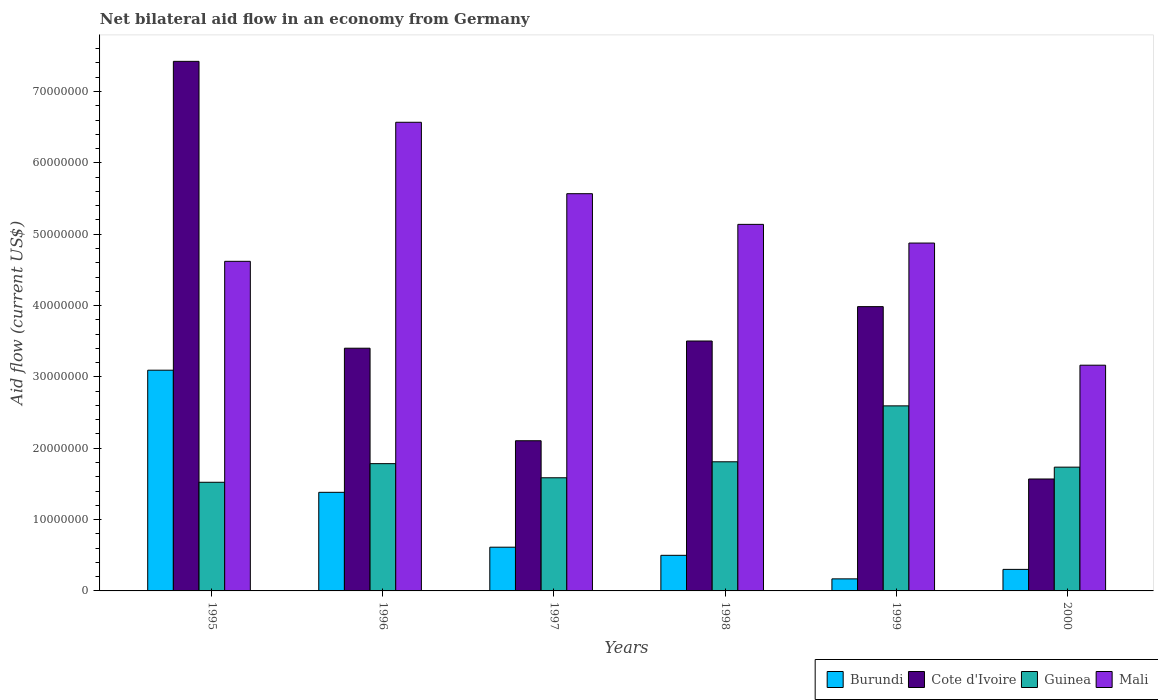Are the number of bars on each tick of the X-axis equal?
Your answer should be compact. Yes. How many bars are there on the 6th tick from the left?
Your response must be concise. 4. What is the label of the 1st group of bars from the left?
Provide a short and direct response. 1995. In how many cases, is the number of bars for a given year not equal to the number of legend labels?
Provide a succinct answer. 0. What is the net bilateral aid flow in Guinea in 1997?
Keep it short and to the point. 1.59e+07. Across all years, what is the maximum net bilateral aid flow in Mali?
Your answer should be very brief. 6.57e+07. Across all years, what is the minimum net bilateral aid flow in Cote d'Ivoire?
Offer a terse response. 1.57e+07. In which year was the net bilateral aid flow in Burundi minimum?
Your response must be concise. 1999. What is the total net bilateral aid flow in Cote d'Ivoire in the graph?
Your answer should be very brief. 2.20e+08. What is the difference between the net bilateral aid flow in Burundi in 1997 and that in 1999?
Give a very brief answer. 4.44e+06. What is the difference between the net bilateral aid flow in Burundi in 1998 and the net bilateral aid flow in Cote d'Ivoire in 1996?
Keep it short and to the point. -2.90e+07. What is the average net bilateral aid flow in Burundi per year?
Keep it short and to the point. 1.01e+07. In the year 1997, what is the difference between the net bilateral aid flow in Burundi and net bilateral aid flow in Cote d'Ivoire?
Offer a very short reply. -1.49e+07. In how many years, is the net bilateral aid flow in Mali greater than 74000000 US$?
Ensure brevity in your answer.  0. What is the ratio of the net bilateral aid flow in Guinea in 1997 to that in 2000?
Your answer should be very brief. 0.91. Is the difference between the net bilateral aid flow in Burundi in 1996 and 1998 greater than the difference between the net bilateral aid flow in Cote d'Ivoire in 1996 and 1998?
Provide a succinct answer. Yes. What is the difference between the highest and the second highest net bilateral aid flow in Burundi?
Your answer should be very brief. 1.71e+07. What is the difference between the highest and the lowest net bilateral aid flow in Guinea?
Offer a very short reply. 1.07e+07. In how many years, is the net bilateral aid flow in Guinea greater than the average net bilateral aid flow in Guinea taken over all years?
Ensure brevity in your answer.  1. Is it the case that in every year, the sum of the net bilateral aid flow in Burundi and net bilateral aid flow in Guinea is greater than the sum of net bilateral aid flow in Mali and net bilateral aid flow in Cote d'Ivoire?
Keep it short and to the point. No. What does the 2nd bar from the left in 1997 represents?
Provide a short and direct response. Cote d'Ivoire. What does the 1st bar from the right in 1999 represents?
Your answer should be very brief. Mali. Are the values on the major ticks of Y-axis written in scientific E-notation?
Keep it short and to the point. No. Does the graph contain grids?
Make the answer very short. No. What is the title of the graph?
Your answer should be compact. Net bilateral aid flow in an economy from Germany. What is the label or title of the Y-axis?
Make the answer very short. Aid flow (current US$). What is the Aid flow (current US$) of Burundi in 1995?
Your response must be concise. 3.09e+07. What is the Aid flow (current US$) in Cote d'Ivoire in 1995?
Your answer should be very brief. 7.42e+07. What is the Aid flow (current US$) in Guinea in 1995?
Keep it short and to the point. 1.52e+07. What is the Aid flow (current US$) of Mali in 1995?
Offer a very short reply. 4.62e+07. What is the Aid flow (current US$) in Burundi in 1996?
Provide a succinct answer. 1.38e+07. What is the Aid flow (current US$) of Cote d'Ivoire in 1996?
Offer a terse response. 3.40e+07. What is the Aid flow (current US$) of Guinea in 1996?
Provide a succinct answer. 1.78e+07. What is the Aid flow (current US$) of Mali in 1996?
Your response must be concise. 6.57e+07. What is the Aid flow (current US$) of Burundi in 1997?
Give a very brief answer. 6.13e+06. What is the Aid flow (current US$) of Cote d'Ivoire in 1997?
Ensure brevity in your answer.  2.10e+07. What is the Aid flow (current US$) of Guinea in 1997?
Provide a short and direct response. 1.59e+07. What is the Aid flow (current US$) of Mali in 1997?
Give a very brief answer. 5.57e+07. What is the Aid flow (current US$) of Burundi in 1998?
Keep it short and to the point. 4.99e+06. What is the Aid flow (current US$) in Cote d'Ivoire in 1998?
Provide a succinct answer. 3.50e+07. What is the Aid flow (current US$) in Guinea in 1998?
Give a very brief answer. 1.81e+07. What is the Aid flow (current US$) in Mali in 1998?
Provide a short and direct response. 5.14e+07. What is the Aid flow (current US$) in Burundi in 1999?
Offer a terse response. 1.69e+06. What is the Aid flow (current US$) in Cote d'Ivoire in 1999?
Your answer should be compact. 3.98e+07. What is the Aid flow (current US$) of Guinea in 1999?
Offer a very short reply. 2.59e+07. What is the Aid flow (current US$) of Mali in 1999?
Provide a succinct answer. 4.88e+07. What is the Aid flow (current US$) of Burundi in 2000?
Your answer should be compact. 3.02e+06. What is the Aid flow (current US$) in Cote d'Ivoire in 2000?
Keep it short and to the point. 1.57e+07. What is the Aid flow (current US$) of Guinea in 2000?
Ensure brevity in your answer.  1.74e+07. What is the Aid flow (current US$) of Mali in 2000?
Provide a succinct answer. 3.16e+07. Across all years, what is the maximum Aid flow (current US$) in Burundi?
Make the answer very short. 3.09e+07. Across all years, what is the maximum Aid flow (current US$) in Cote d'Ivoire?
Offer a very short reply. 7.42e+07. Across all years, what is the maximum Aid flow (current US$) of Guinea?
Your response must be concise. 2.59e+07. Across all years, what is the maximum Aid flow (current US$) in Mali?
Provide a succinct answer. 6.57e+07. Across all years, what is the minimum Aid flow (current US$) in Burundi?
Give a very brief answer. 1.69e+06. Across all years, what is the minimum Aid flow (current US$) of Cote d'Ivoire?
Ensure brevity in your answer.  1.57e+07. Across all years, what is the minimum Aid flow (current US$) of Guinea?
Provide a short and direct response. 1.52e+07. Across all years, what is the minimum Aid flow (current US$) of Mali?
Offer a very short reply. 3.16e+07. What is the total Aid flow (current US$) in Burundi in the graph?
Offer a terse response. 6.06e+07. What is the total Aid flow (current US$) in Cote d'Ivoire in the graph?
Offer a very short reply. 2.20e+08. What is the total Aid flow (current US$) of Guinea in the graph?
Keep it short and to the point. 1.10e+08. What is the total Aid flow (current US$) in Mali in the graph?
Offer a terse response. 2.99e+08. What is the difference between the Aid flow (current US$) in Burundi in 1995 and that in 1996?
Offer a very short reply. 1.71e+07. What is the difference between the Aid flow (current US$) in Cote d'Ivoire in 1995 and that in 1996?
Provide a short and direct response. 4.02e+07. What is the difference between the Aid flow (current US$) of Guinea in 1995 and that in 1996?
Give a very brief answer. -2.61e+06. What is the difference between the Aid flow (current US$) of Mali in 1995 and that in 1996?
Your response must be concise. -1.95e+07. What is the difference between the Aid flow (current US$) in Burundi in 1995 and that in 1997?
Offer a very short reply. 2.48e+07. What is the difference between the Aid flow (current US$) of Cote d'Ivoire in 1995 and that in 1997?
Your answer should be very brief. 5.32e+07. What is the difference between the Aid flow (current US$) of Guinea in 1995 and that in 1997?
Ensure brevity in your answer.  -6.30e+05. What is the difference between the Aid flow (current US$) in Mali in 1995 and that in 1997?
Make the answer very short. -9.48e+06. What is the difference between the Aid flow (current US$) in Burundi in 1995 and that in 1998?
Make the answer very short. 2.60e+07. What is the difference between the Aid flow (current US$) of Cote d'Ivoire in 1995 and that in 1998?
Your answer should be compact. 3.92e+07. What is the difference between the Aid flow (current US$) of Guinea in 1995 and that in 1998?
Offer a very short reply. -2.87e+06. What is the difference between the Aid flow (current US$) in Mali in 1995 and that in 1998?
Provide a succinct answer. -5.18e+06. What is the difference between the Aid flow (current US$) of Burundi in 1995 and that in 1999?
Provide a short and direct response. 2.92e+07. What is the difference between the Aid flow (current US$) in Cote d'Ivoire in 1995 and that in 1999?
Give a very brief answer. 3.44e+07. What is the difference between the Aid flow (current US$) in Guinea in 1995 and that in 1999?
Your answer should be compact. -1.07e+07. What is the difference between the Aid flow (current US$) of Mali in 1995 and that in 1999?
Offer a very short reply. -2.56e+06. What is the difference between the Aid flow (current US$) in Burundi in 1995 and that in 2000?
Provide a succinct answer. 2.79e+07. What is the difference between the Aid flow (current US$) in Cote d'Ivoire in 1995 and that in 2000?
Keep it short and to the point. 5.85e+07. What is the difference between the Aid flow (current US$) of Guinea in 1995 and that in 2000?
Provide a short and direct response. -2.12e+06. What is the difference between the Aid flow (current US$) of Mali in 1995 and that in 2000?
Make the answer very short. 1.46e+07. What is the difference between the Aid flow (current US$) in Burundi in 1996 and that in 1997?
Make the answer very short. 7.69e+06. What is the difference between the Aid flow (current US$) of Cote d'Ivoire in 1996 and that in 1997?
Give a very brief answer. 1.30e+07. What is the difference between the Aid flow (current US$) of Guinea in 1996 and that in 1997?
Make the answer very short. 1.98e+06. What is the difference between the Aid flow (current US$) in Mali in 1996 and that in 1997?
Provide a short and direct response. 1.00e+07. What is the difference between the Aid flow (current US$) of Burundi in 1996 and that in 1998?
Your response must be concise. 8.83e+06. What is the difference between the Aid flow (current US$) in Cote d'Ivoire in 1996 and that in 1998?
Make the answer very short. -1.01e+06. What is the difference between the Aid flow (current US$) in Mali in 1996 and that in 1998?
Provide a short and direct response. 1.43e+07. What is the difference between the Aid flow (current US$) in Burundi in 1996 and that in 1999?
Provide a short and direct response. 1.21e+07. What is the difference between the Aid flow (current US$) in Cote d'Ivoire in 1996 and that in 1999?
Keep it short and to the point. -5.83e+06. What is the difference between the Aid flow (current US$) in Guinea in 1996 and that in 1999?
Provide a short and direct response. -8.10e+06. What is the difference between the Aid flow (current US$) in Mali in 1996 and that in 1999?
Give a very brief answer. 1.69e+07. What is the difference between the Aid flow (current US$) of Burundi in 1996 and that in 2000?
Give a very brief answer. 1.08e+07. What is the difference between the Aid flow (current US$) of Cote d'Ivoire in 1996 and that in 2000?
Your answer should be compact. 1.83e+07. What is the difference between the Aid flow (current US$) of Mali in 1996 and that in 2000?
Make the answer very short. 3.40e+07. What is the difference between the Aid flow (current US$) of Burundi in 1997 and that in 1998?
Your answer should be very brief. 1.14e+06. What is the difference between the Aid flow (current US$) of Cote d'Ivoire in 1997 and that in 1998?
Provide a short and direct response. -1.40e+07. What is the difference between the Aid flow (current US$) of Guinea in 1997 and that in 1998?
Offer a terse response. -2.24e+06. What is the difference between the Aid flow (current US$) of Mali in 1997 and that in 1998?
Keep it short and to the point. 4.30e+06. What is the difference between the Aid flow (current US$) in Burundi in 1997 and that in 1999?
Keep it short and to the point. 4.44e+06. What is the difference between the Aid flow (current US$) in Cote d'Ivoire in 1997 and that in 1999?
Your answer should be very brief. -1.88e+07. What is the difference between the Aid flow (current US$) of Guinea in 1997 and that in 1999?
Offer a very short reply. -1.01e+07. What is the difference between the Aid flow (current US$) of Mali in 1997 and that in 1999?
Offer a terse response. 6.92e+06. What is the difference between the Aid flow (current US$) in Burundi in 1997 and that in 2000?
Your response must be concise. 3.11e+06. What is the difference between the Aid flow (current US$) in Cote d'Ivoire in 1997 and that in 2000?
Make the answer very short. 5.36e+06. What is the difference between the Aid flow (current US$) in Guinea in 1997 and that in 2000?
Keep it short and to the point. -1.49e+06. What is the difference between the Aid flow (current US$) in Mali in 1997 and that in 2000?
Provide a short and direct response. 2.40e+07. What is the difference between the Aid flow (current US$) of Burundi in 1998 and that in 1999?
Make the answer very short. 3.30e+06. What is the difference between the Aid flow (current US$) in Cote d'Ivoire in 1998 and that in 1999?
Offer a very short reply. -4.82e+06. What is the difference between the Aid flow (current US$) of Guinea in 1998 and that in 1999?
Your answer should be very brief. -7.84e+06. What is the difference between the Aid flow (current US$) in Mali in 1998 and that in 1999?
Give a very brief answer. 2.62e+06. What is the difference between the Aid flow (current US$) of Burundi in 1998 and that in 2000?
Make the answer very short. 1.97e+06. What is the difference between the Aid flow (current US$) in Cote d'Ivoire in 1998 and that in 2000?
Give a very brief answer. 1.93e+07. What is the difference between the Aid flow (current US$) in Guinea in 1998 and that in 2000?
Provide a succinct answer. 7.50e+05. What is the difference between the Aid flow (current US$) of Mali in 1998 and that in 2000?
Keep it short and to the point. 1.97e+07. What is the difference between the Aid flow (current US$) in Burundi in 1999 and that in 2000?
Give a very brief answer. -1.33e+06. What is the difference between the Aid flow (current US$) of Cote d'Ivoire in 1999 and that in 2000?
Make the answer very short. 2.42e+07. What is the difference between the Aid flow (current US$) of Guinea in 1999 and that in 2000?
Give a very brief answer. 8.59e+06. What is the difference between the Aid flow (current US$) in Mali in 1999 and that in 2000?
Keep it short and to the point. 1.71e+07. What is the difference between the Aid flow (current US$) of Burundi in 1995 and the Aid flow (current US$) of Cote d'Ivoire in 1996?
Offer a very short reply. -3.08e+06. What is the difference between the Aid flow (current US$) in Burundi in 1995 and the Aid flow (current US$) in Guinea in 1996?
Offer a very short reply. 1.31e+07. What is the difference between the Aid flow (current US$) of Burundi in 1995 and the Aid flow (current US$) of Mali in 1996?
Make the answer very short. -3.48e+07. What is the difference between the Aid flow (current US$) of Cote d'Ivoire in 1995 and the Aid flow (current US$) of Guinea in 1996?
Make the answer very short. 5.64e+07. What is the difference between the Aid flow (current US$) of Cote d'Ivoire in 1995 and the Aid flow (current US$) of Mali in 1996?
Offer a very short reply. 8.54e+06. What is the difference between the Aid flow (current US$) of Guinea in 1995 and the Aid flow (current US$) of Mali in 1996?
Provide a succinct answer. -5.05e+07. What is the difference between the Aid flow (current US$) in Burundi in 1995 and the Aid flow (current US$) in Cote d'Ivoire in 1997?
Make the answer very short. 9.89e+06. What is the difference between the Aid flow (current US$) of Burundi in 1995 and the Aid flow (current US$) of Guinea in 1997?
Provide a succinct answer. 1.51e+07. What is the difference between the Aid flow (current US$) in Burundi in 1995 and the Aid flow (current US$) in Mali in 1997?
Offer a very short reply. -2.47e+07. What is the difference between the Aid flow (current US$) in Cote d'Ivoire in 1995 and the Aid flow (current US$) in Guinea in 1997?
Keep it short and to the point. 5.84e+07. What is the difference between the Aid flow (current US$) of Cote d'Ivoire in 1995 and the Aid flow (current US$) of Mali in 1997?
Your answer should be compact. 1.86e+07. What is the difference between the Aid flow (current US$) in Guinea in 1995 and the Aid flow (current US$) in Mali in 1997?
Your response must be concise. -4.04e+07. What is the difference between the Aid flow (current US$) in Burundi in 1995 and the Aid flow (current US$) in Cote d'Ivoire in 1998?
Offer a terse response. -4.09e+06. What is the difference between the Aid flow (current US$) in Burundi in 1995 and the Aid flow (current US$) in Guinea in 1998?
Give a very brief answer. 1.28e+07. What is the difference between the Aid flow (current US$) in Burundi in 1995 and the Aid flow (current US$) in Mali in 1998?
Provide a succinct answer. -2.04e+07. What is the difference between the Aid flow (current US$) in Cote d'Ivoire in 1995 and the Aid flow (current US$) in Guinea in 1998?
Keep it short and to the point. 5.61e+07. What is the difference between the Aid flow (current US$) of Cote d'Ivoire in 1995 and the Aid flow (current US$) of Mali in 1998?
Keep it short and to the point. 2.28e+07. What is the difference between the Aid flow (current US$) of Guinea in 1995 and the Aid flow (current US$) of Mali in 1998?
Ensure brevity in your answer.  -3.62e+07. What is the difference between the Aid flow (current US$) of Burundi in 1995 and the Aid flow (current US$) of Cote d'Ivoire in 1999?
Provide a short and direct response. -8.91e+06. What is the difference between the Aid flow (current US$) in Burundi in 1995 and the Aid flow (current US$) in Guinea in 1999?
Keep it short and to the point. 5.00e+06. What is the difference between the Aid flow (current US$) of Burundi in 1995 and the Aid flow (current US$) of Mali in 1999?
Make the answer very short. -1.78e+07. What is the difference between the Aid flow (current US$) of Cote d'Ivoire in 1995 and the Aid flow (current US$) of Guinea in 1999?
Ensure brevity in your answer.  4.83e+07. What is the difference between the Aid flow (current US$) of Cote d'Ivoire in 1995 and the Aid flow (current US$) of Mali in 1999?
Offer a terse response. 2.55e+07. What is the difference between the Aid flow (current US$) of Guinea in 1995 and the Aid flow (current US$) of Mali in 1999?
Offer a very short reply. -3.35e+07. What is the difference between the Aid flow (current US$) of Burundi in 1995 and the Aid flow (current US$) of Cote d'Ivoire in 2000?
Give a very brief answer. 1.52e+07. What is the difference between the Aid flow (current US$) in Burundi in 1995 and the Aid flow (current US$) in Guinea in 2000?
Give a very brief answer. 1.36e+07. What is the difference between the Aid flow (current US$) of Burundi in 1995 and the Aid flow (current US$) of Mali in 2000?
Offer a very short reply. -7.00e+05. What is the difference between the Aid flow (current US$) of Cote d'Ivoire in 1995 and the Aid flow (current US$) of Guinea in 2000?
Your answer should be compact. 5.69e+07. What is the difference between the Aid flow (current US$) of Cote d'Ivoire in 1995 and the Aid flow (current US$) of Mali in 2000?
Offer a terse response. 4.26e+07. What is the difference between the Aid flow (current US$) of Guinea in 1995 and the Aid flow (current US$) of Mali in 2000?
Your answer should be compact. -1.64e+07. What is the difference between the Aid flow (current US$) in Burundi in 1996 and the Aid flow (current US$) in Cote d'Ivoire in 1997?
Provide a succinct answer. -7.23e+06. What is the difference between the Aid flow (current US$) of Burundi in 1996 and the Aid flow (current US$) of Guinea in 1997?
Ensure brevity in your answer.  -2.04e+06. What is the difference between the Aid flow (current US$) in Burundi in 1996 and the Aid flow (current US$) in Mali in 1997?
Offer a very short reply. -4.19e+07. What is the difference between the Aid flow (current US$) in Cote d'Ivoire in 1996 and the Aid flow (current US$) in Guinea in 1997?
Offer a very short reply. 1.82e+07. What is the difference between the Aid flow (current US$) of Cote d'Ivoire in 1996 and the Aid flow (current US$) of Mali in 1997?
Ensure brevity in your answer.  -2.17e+07. What is the difference between the Aid flow (current US$) in Guinea in 1996 and the Aid flow (current US$) in Mali in 1997?
Make the answer very short. -3.78e+07. What is the difference between the Aid flow (current US$) of Burundi in 1996 and the Aid flow (current US$) of Cote d'Ivoire in 1998?
Keep it short and to the point. -2.12e+07. What is the difference between the Aid flow (current US$) in Burundi in 1996 and the Aid flow (current US$) in Guinea in 1998?
Your answer should be compact. -4.28e+06. What is the difference between the Aid flow (current US$) of Burundi in 1996 and the Aid flow (current US$) of Mali in 1998?
Provide a short and direct response. -3.76e+07. What is the difference between the Aid flow (current US$) of Cote d'Ivoire in 1996 and the Aid flow (current US$) of Guinea in 1998?
Provide a short and direct response. 1.59e+07. What is the difference between the Aid flow (current US$) in Cote d'Ivoire in 1996 and the Aid flow (current US$) in Mali in 1998?
Give a very brief answer. -1.74e+07. What is the difference between the Aid flow (current US$) in Guinea in 1996 and the Aid flow (current US$) in Mali in 1998?
Your answer should be very brief. -3.35e+07. What is the difference between the Aid flow (current US$) in Burundi in 1996 and the Aid flow (current US$) in Cote d'Ivoire in 1999?
Provide a short and direct response. -2.60e+07. What is the difference between the Aid flow (current US$) of Burundi in 1996 and the Aid flow (current US$) of Guinea in 1999?
Offer a terse response. -1.21e+07. What is the difference between the Aid flow (current US$) of Burundi in 1996 and the Aid flow (current US$) of Mali in 1999?
Your answer should be very brief. -3.49e+07. What is the difference between the Aid flow (current US$) of Cote d'Ivoire in 1996 and the Aid flow (current US$) of Guinea in 1999?
Offer a very short reply. 8.08e+06. What is the difference between the Aid flow (current US$) of Cote d'Ivoire in 1996 and the Aid flow (current US$) of Mali in 1999?
Make the answer very short. -1.47e+07. What is the difference between the Aid flow (current US$) of Guinea in 1996 and the Aid flow (current US$) of Mali in 1999?
Ensure brevity in your answer.  -3.09e+07. What is the difference between the Aid flow (current US$) in Burundi in 1996 and the Aid flow (current US$) in Cote d'Ivoire in 2000?
Your answer should be compact. -1.87e+06. What is the difference between the Aid flow (current US$) in Burundi in 1996 and the Aid flow (current US$) in Guinea in 2000?
Your answer should be very brief. -3.53e+06. What is the difference between the Aid flow (current US$) of Burundi in 1996 and the Aid flow (current US$) of Mali in 2000?
Provide a succinct answer. -1.78e+07. What is the difference between the Aid flow (current US$) of Cote d'Ivoire in 1996 and the Aid flow (current US$) of Guinea in 2000?
Ensure brevity in your answer.  1.67e+07. What is the difference between the Aid flow (current US$) in Cote d'Ivoire in 1996 and the Aid flow (current US$) in Mali in 2000?
Offer a terse response. 2.38e+06. What is the difference between the Aid flow (current US$) of Guinea in 1996 and the Aid flow (current US$) of Mali in 2000?
Provide a short and direct response. -1.38e+07. What is the difference between the Aid flow (current US$) of Burundi in 1997 and the Aid flow (current US$) of Cote d'Ivoire in 1998?
Your response must be concise. -2.89e+07. What is the difference between the Aid flow (current US$) of Burundi in 1997 and the Aid flow (current US$) of Guinea in 1998?
Keep it short and to the point. -1.20e+07. What is the difference between the Aid flow (current US$) in Burundi in 1997 and the Aid flow (current US$) in Mali in 1998?
Provide a succinct answer. -4.52e+07. What is the difference between the Aid flow (current US$) in Cote d'Ivoire in 1997 and the Aid flow (current US$) in Guinea in 1998?
Keep it short and to the point. 2.95e+06. What is the difference between the Aid flow (current US$) of Cote d'Ivoire in 1997 and the Aid flow (current US$) of Mali in 1998?
Your answer should be very brief. -3.03e+07. What is the difference between the Aid flow (current US$) in Guinea in 1997 and the Aid flow (current US$) in Mali in 1998?
Your response must be concise. -3.55e+07. What is the difference between the Aid flow (current US$) in Burundi in 1997 and the Aid flow (current US$) in Cote d'Ivoire in 1999?
Your response must be concise. -3.37e+07. What is the difference between the Aid flow (current US$) in Burundi in 1997 and the Aid flow (current US$) in Guinea in 1999?
Keep it short and to the point. -1.98e+07. What is the difference between the Aid flow (current US$) of Burundi in 1997 and the Aid flow (current US$) of Mali in 1999?
Offer a terse response. -4.26e+07. What is the difference between the Aid flow (current US$) of Cote d'Ivoire in 1997 and the Aid flow (current US$) of Guinea in 1999?
Keep it short and to the point. -4.89e+06. What is the difference between the Aid flow (current US$) of Cote d'Ivoire in 1997 and the Aid flow (current US$) of Mali in 1999?
Your response must be concise. -2.77e+07. What is the difference between the Aid flow (current US$) in Guinea in 1997 and the Aid flow (current US$) in Mali in 1999?
Provide a short and direct response. -3.29e+07. What is the difference between the Aid flow (current US$) of Burundi in 1997 and the Aid flow (current US$) of Cote d'Ivoire in 2000?
Your response must be concise. -9.56e+06. What is the difference between the Aid flow (current US$) in Burundi in 1997 and the Aid flow (current US$) in Guinea in 2000?
Your answer should be compact. -1.12e+07. What is the difference between the Aid flow (current US$) in Burundi in 1997 and the Aid flow (current US$) in Mali in 2000?
Keep it short and to the point. -2.55e+07. What is the difference between the Aid flow (current US$) of Cote d'Ivoire in 1997 and the Aid flow (current US$) of Guinea in 2000?
Make the answer very short. 3.70e+06. What is the difference between the Aid flow (current US$) in Cote d'Ivoire in 1997 and the Aid flow (current US$) in Mali in 2000?
Your answer should be very brief. -1.06e+07. What is the difference between the Aid flow (current US$) of Guinea in 1997 and the Aid flow (current US$) of Mali in 2000?
Ensure brevity in your answer.  -1.58e+07. What is the difference between the Aid flow (current US$) of Burundi in 1998 and the Aid flow (current US$) of Cote d'Ivoire in 1999?
Make the answer very short. -3.49e+07. What is the difference between the Aid flow (current US$) of Burundi in 1998 and the Aid flow (current US$) of Guinea in 1999?
Provide a succinct answer. -2.10e+07. What is the difference between the Aid flow (current US$) of Burundi in 1998 and the Aid flow (current US$) of Mali in 1999?
Offer a terse response. -4.38e+07. What is the difference between the Aid flow (current US$) in Cote d'Ivoire in 1998 and the Aid flow (current US$) in Guinea in 1999?
Provide a short and direct response. 9.09e+06. What is the difference between the Aid flow (current US$) of Cote d'Ivoire in 1998 and the Aid flow (current US$) of Mali in 1999?
Offer a very short reply. -1.37e+07. What is the difference between the Aid flow (current US$) of Guinea in 1998 and the Aid flow (current US$) of Mali in 1999?
Offer a very short reply. -3.07e+07. What is the difference between the Aid flow (current US$) in Burundi in 1998 and the Aid flow (current US$) in Cote d'Ivoire in 2000?
Offer a terse response. -1.07e+07. What is the difference between the Aid flow (current US$) in Burundi in 1998 and the Aid flow (current US$) in Guinea in 2000?
Offer a terse response. -1.24e+07. What is the difference between the Aid flow (current US$) in Burundi in 1998 and the Aid flow (current US$) in Mali in 2000?
Keep it short and to the point. -2.66e+07. What is the difference between the Aid flow (current US$) of Cote d'Ivoire in 1998 and the Aid flow (current US$) of Guinea in 2000?
Your answer should be compact. 1.77e+07. What is the difference between the Aid flow (current US$) of Cote d'Ivoire in 1998 and the Aid flow (current US$) of Mali in 2000?
Provide a succinct answer. 3.39e+06. What is the difference between the Aid flow (current US$) of Guinea in 1998 and the Aid flow (current US$) of Mali in 2000?
Offer a terse response. -1.35e+07. What is the difference between the Aid flow (current US$) of Burundi in 1999 and the Aid flow (current US$) of Cote d'Ivoire in 2000?
Your response must be concise. -1.40e+07. What is the difference between the Aid flow (current US$) of Burundi in 1999 and the Aid flow (current US$) of Guinea in 2000?
Your response must be concise. -1.57e+07. What is the difference between the Aid flow (current US$) in Burundi in 1999 and the Aid flow (current US$) in Mali in 2000?
Keep it short and to the point. -3.00e+07. What is the difference between the Aid flow (current US$) of Cote d'Ivoire in 1999 and the Aid flow (current US$) of Guinea in 2000?
Keep it short and to the point. 2.25e+07. What is the difference between the Aid flow (current US$) of Cote d'Ivoire in 1999 and the Aid flow (current US$) of Mali in 2000?
Keep it short and to the point. 8.21e+06. What is the difference between the Aid flow (current US$) of Guinea in 1999 and the Aid flow (current US$) of Mali in 2000?
Give a very brief answer. -5.70e+06. What is the average Aid flow (current US$) in Burundi per year?
Keep it short and to the point. 1.01e+07. What is the average Aid flow (current US$) of Cote d'Ivoire per year?
Keep it short and to the point. 3.66e+07. What is the average Aid flow (current US$) in Guinea per year?
Give a very brief answer. 1.84e+07. What is the average Aid flow (current US$) of Mali per year?
Your response must be concise. 4.99e+07. In the year 1995, what is the difference between the Aid flow (current US$) of Burundi and Aid flow (current US$) of Cote d'Ivoire?
Offer a very short reply. -4.33e+07. In the year 1995, what is the difference between the Aid flow (current US$) in Burundi and Aid flow (current US$) in Guinea?
Your answer should be very brief. 1.57e+07. In the year 1995, what is the difference between the Aid flow (current US$) in Burundi and Aid flow (current US$) in Mali?
Provide a succinct answer. -1.53e+07. In the year 1995, what is the difference between the Aid flow (current US$) of Cote d'Ivoire and Aid flow (current US$) of Guinea?
Offer a terse response. 5.90e+07. In the year 1995, what is the difference between the Aid flow (current US$) of Cote d'Ivoire and Aid flow (current US$) of Mali?
Provide a short and direct response. 2.80e+07. In the year 1995, what is the difference between the Aid flow (current US$) of Guinea and Aid flow (current US$) of Mali?
Ensure brevity in your answer.  -3.10e+07. In the year 1996, what is the difference between the Aid flow (current US$) of Burundi and Aid flow (current US$) of Cote d'Ivoire?
Your answer should be very brief. -2.02e+07. In the year 1996, what is the difference between the Aid flow (current US$) of Burundi and Aid flow (current US$) of Guinea?
Make the answer very short. -4.02e+06. In the year 1996, what is the difference between the Aid flow (current US$) of Burundi and Aid flow (current US$) of Mali?
Your answer should be compact. -5.19e+07. In the year 1996, what is the difference between the Aid flow (current US$) in Cote d'Ivoire and Aid flow (current US$) in Guinea?
Provide a short and direct response. 1.62e+07. In the year 1996, what is the difference between the Aid flow (current US$) in Cote d'Ivoire and Aid flow (current US$) in Mali?
Provide a short and direct response. -3.17e+07. In the year 1996, what is the difference between the Aid flow (current US$) of Guinea and Aid flow (current US$) of Mali?
Your answer should be compact. -4.78e+07. In the year 1997, what is the difference between the Aid flow (current US$) in Burundi and Aid flow (current US$) in Cote d'Ivoire?
Your answer should be very brief. -1.49e+07. In the year 1997, what is the difference between the Aid flow (current US$) in Burundi and Aid flow (current US$) in Guinea?
Your answer should be compact. -9.73e+06. In the year 1997, what is the difference between the Aid flow (current US$) of Burundi and Aid flow (current US$) of Mali?
Offer a terse response. -4.96e+07. In the year 1997, what is the difference between the Aid flow (current US$) in Cote d'Ivoire and Aid flow (current US$) in Guinea?
Your answer should be very brief. 5.19e+06. In the year 1997, what is the difference between the Aid flow (current US$) of Cote d'Ivoire and Aid flow (current US$) of Mali?
Give a very brief answer. -3.46e+07. In the year 1997, what is the difference between the Aid flow (current US$) in Guinea and Aid flow (current US$) in Mali?
Ensure brevity in your answer.  -3.98e+07. In the year 1998, what is the difference between the Aid flow (current US$) of Burundi and Aid flow (current US$) of Cote d'Ivoire?
Your answer should be compact. -3.00e+07. In the year 1998, what is the difference between the Aid flow (current US$) of Burundi and Aid flow (current US$) of Guinea?
Your answer should be very brief. -1.31e+07. In the year 1998, what is the difference between the Aid flow (current US$) of Burundi and Aid flow (current US$) of Mali?
Make the answer very short. -4.64e+07. In the year 1998, what is the difference between the Aid flow (current US$) of Cote d'Ivoire and Aid flow (current US$) of Guinea?
Your answer should be compact. 1.69e+07. In the year 1998, what is the difference between the Aid flow (current US$) of Cote d'Ivoire and Aid flow (current US$) of Mali?
Your response must be concise. -1.64e+07. In the year 1998, what is the difference between the Aid flow (current US$) of Guinea and Aid flow (current US$) of Mali?
Make the answer very short. -3.33e+07. In the year 1999, what is the difference between the Aid flow (current US$) of Burundi and Aid flow (current US$) of Cote d'Ivoire?
Keep it short and to the point. -3.82e+07. In the year 1999, what is the difference between the Aid flow (current US$) of Burundi and Aid flow (current US$) of Guinea?
Provide a short and direct response. -2.42e+07. In the year 1999, what is the difference between the Aid flow (current US$) in Burundi and Aid flow (current US$) in Mali?
Offer a terse response. -4.71e+07. In the year 1999, what is the difference between the Aid flow (current US$) in Cote d'Ivoire and Aid flow (current US$) in Guinea?
Offer a very short reply. 1.39e+07. In the year 1999, what is the difference between the Aid flow (current US$) in Cote d'Ivoire and Aid flow (current US$) in Mali?
Your response must be concise. -8.91e+06. In the year 1999, what is the difference between the Aid flow (current US$) of Guinea and Aid flow (current US$) of Mali?
Your answer should be very brief. -2.28e+07. In the year 2000, what is the difference between the Aid flow (current US$) in Burundi and Aid flow (current US$) in Cote d'Ivoire?
Offer a very short reply. -1.27e+07. In the year 2000, what is the difference between the Aid flow (current US$) of Burundi and Aid flow (current US$) of Guinea?
Offer a very short reply. -1.43e+07. In the year 2000, what is the difference between the Aid flow (current US$) in Burundi and Aid flow (current US$) in Mali?
Your response must be concise. -2.86e+07. In the year 2000, what is the difference between the Aid flow (current US$) in Cote d'Ivoire and Aid flow (current US$) in Guinea?
Your response must be concise. -1.66e+06. In the year 2000, what is the difference between the Aid flow (current US$) of Cote d'Ivoire and Aid flow (current US$) of Mali?
Your answer should be compact. -1.60e+07. In the year 2000, what is the difference between the Aid flow (current US$) in Guinea and Aid flow (current US$) in Mali?
Ensure brevity in your answer.  -1.43e+07. What is the ratio of the Aid flow (current US$) in Burundi in 1995 to that in 1996?
Make the answer very short. 2.24. What is the ratio of the Aid flow (current US$) in Cote d'Ivoire in 1995 to that in 1996?
Keep it short and to the point. 2.18. What is the ratio of the Aid flow (current US$) in Guinea in 1995 to that in 1996?
Offer a terse response. 0.85. What is the ratio of the Aid flow (current US$) in Mali in 1995 to that in 1996?
Ensure brevity in your answer.  0.7. What is the ratio of the Aid flow (current US$) of Burundi in 1995 to that in 1997?
Provide a succinct answer. 5.05. What is the ratio of the Aid flow (current US$) in Cote d'Ivoire in 1995 to that in 1997?
Ensure brevity in your answer.  3.53. What is the ratio of the Aid flow (current US$) in Guinea in 1995 to that in 1997?
Your answer should be compact. 0.96. What is the ratio of the Aid flow (current US$) of Mali in 1995 to that in 1997?
Give a very brief answer. 0.83. What is the ratio of the Aid flow (current US$) in Burundi in 1995 to that in 1998?
Your answer should be compact. 6.2. What is the ratio of the Aid flow (current US$) in Cote d'Ivoire in 1995 to that in 1998?
Your response must be concise. 2.12. What is the ratio of the Aid flow (current US$) of Guinea in 1995 to that in 1998?
Your answer should be very brief. 0.84. What is the ratio of the Aid flow (current US$) in Mali in 1995 to that in 1998?
Provide a succinct answer. 0.9. What is the ratio of the Aid flow (current US$) of Burundi in 1995 to that in 1999?
Offer a terse response. 18.31. What is the ratio of the Aid flow (current US$) of Cote d'Ivoire in 1995 to that in 1999?
Make the answer very short. 1.86. What is the ratio of the Aid flow (current US$) of Guinea in 1995 to that in 1999?
Your answer should be very brief. 0.59. What is the ratio of the Aid flow (current US$) of Mali in 1995 to that in 1999?
Your answer should be very brief. 0.95. What is the ratio of the Aid flow (current US$) in Burundi in 1995 to that in 2000?
Offer a very short reply. 10.24. What is the ratio of the Aid flow (current US$) of Cote d'Ivoire in 1995 to that in 2000?
Your answer should be compact. 4.73. What is the ratio of the Aid flow (current US$) of Guinea in 1995 to that in 2000?
Provide a succinct answer. 0.88. What is the ratio of the Aid flow (current US$) in Mali in 1995 to that in 2000?
Your response must be concise. 1.46. What is the ratio of the Aid flow (current US$) in Burundi in 1996 to that in 1997?
Offer a terse response. 2.25. What is the ratio of the Aid flow (current US$) in Cote d'Ivoire in 1996 to that in 1997?
Your response must be concise. 1.62. What is the ratio of the Aid flow (current US$) in Guinea in 1996 to that in 1997?
Provide a short and direct response. 1.12. What is the ratio of the Aid flow (current US$) in Mali in 1996 to that in 1997?
Provide a short and direct response. 1.18. What is the ratio of the Aid flow (current US$) of Burundi in 1996 to that in 1998?
Offer a very short reply. 2.77. What is the ratio of the Aid flow (current US$) of Cote d'Ivoire in 1996 to that in 1998?
Give a very brief answer. 0.97. What is the ratio of the Aid flow (current US$) of Guinea in 1996 to that in 1998?
Offer a terse response. 0.99. What is the ratio of the Aid flow (current US$) of Mali in 1996 to that in 1998?
Your answer should be compact. 1.28. What is the ratio of the Aid flow (current US$) of Burundi in 1996 to that in 1999?
Provide a succinct answer. 8.18. What is the ratio of the Aid flow (current US$) of Cote d'Ivoire in 1996 to that in 1999?
Provide a succinct answer. 0.85. What is the ratio of the Aid flow (current US$) in Guinea in 1996 to that in 1999?
Give a very brief answer. 0.69. What is the ratio of the Aid flow (current US$) of Mali in 1996 to that in 1999?
Your answer should be very brief. 1.35. What is the ratio of the Aid flow (current US$) in Burundi in 1996 to that in 2000?
Make the answer very short. 4.58. What is the ratio of the Aid flow (current US$) of Cote d'Ivoire in 1996 to that in 2000?
Offer a terse response. 2.17. What is the ratio of the Aid flow (current US$) of Guinea in 1996 to that in 2000?
Provide a succinct answer. 1.03. What is the ratio of the Aid flow (current US$) in Mali in 1996 to that in 2000?
Your answer should be very brief. 2.08. What is the ratio of the Aid flow (current US$) in Burundi in 1997 to that in 1998?
Provide a succinct answer. 1.23. What is the ratio of the Aid flow (current US$) of Cote d'Ivoire in 1997 to that in 1998?
Ensure brevity in your answer.  0.6. What is the ratio of the Aid flow (current US$) in Guinea in 1997 to that in 1998?
Offer a very short reply. 0.88. What is the ratio of the Aid flow (current US$) in Mali in 1997 to that in 1998?
Your response must be concise. 1.08. What is the ratio of the Aid flow (current US$) in Burundi in 1997 to that in 1999?
Offer a terse response. 3.63. What is the ratio of the Aid flow (current US$) of Cote d'Ivoire in 1997 to that in 1999?
Offer a very short reply. 0.53. What is the ratio of the Aid flow (current US$) of Guinea in 1997 to that in 1999?
Your response must be concise. 0.61. What is the ratio of the Aid flow (current US$) of Mali in 1997 to that in 1999?
Offer a terse response. 1.14. What is the ratio of the Aid flow (current US$) of Burundi in 1997 to that in 2000?
Your response must be concise. 2.03. What is the ratio of the Aid flow (current US$) in Cote d'Ivoire in 1997 to that in 2000?
Provide a succinct answer. 1.34. What is the ratio of the Aid flow (current US$) in Guinea in 1997 to that in 2000?
Make the answer very short. 0.91. What is the ratio of the Aid flow (current US$) in Mali in 1997 to that in 2000?
Keep it short and to the point. 1.76. What is the ratio of the Aid flow (current US$) of Burundi in 1998 to that in 1999?
Your answer should be compact. 2.95. What is the ratio of the Aid flow (current US$) in Cote d'Ivoire in 1998 to that in 1999?
Your response must be concise. 0.88. What is the ratio of the Aid flow (current US$) of Guinea in 1998 to that in 1999?
Keep it short and to the point. 0.7. What is the ratio of the Aid flow (current US$) in Mali in 1998 to that in 1999?
Give a very brief answer. 1.05. What is the ratio of the Aid flow (current US$) of Burundi in 1998 to that in 2000?
Offer a very short reply. 1.65. What is the ratio of the Aid flow (current US$) of Cote d'Ivoire in 1998 to that in 2000?
Make the answer very short. 2.23. What is the ratio of the Aid flow (current US$) in Guinea in 1998 to that in 2000?
Keep it short and to the point. 1.04. What is the ratio of the Aid flow (current US$) in Mali in 1998 to that in 2000?
Provide a short and direct response. 1.62. What is the ratio of the Aid flow (current US$) in Burundi in 1999 to that in 2000?
Your answer should be very brief. 0.56. What is the ratio of the Aid flow (current US$) of Cote d'Ivoire in 1999 to that in 2000?
Offer a very short reply. 2.54. What is the ratio of the Aid flow (current US$) in Guinea in 1999 to that in 2000?
Provide a short and direct response. 1.5. What is the ratio of the Aid flow (current US$) of Mali in 1999 to that in 2000?
Provide a succinct answer. 1.54. What is the difference between the highest and the second highest Aid flow (current US$) in Burundi?
Your answer should be very brief. 1.71e+07. What is the difference between the highest and the second highest Aid flow (current US$) of Cote d'Ivoire?
Keep it short and to the point. 3.44e+07. What is the difference between the highest and the second highest Aid flow (current US$) of Guinea?
Offer a very short reply. 7.84e+06. What is the difference between the highest and the second highest Aid flow (current US$) of Mali?
Provide a short and direct response. 1.00e+07. What is the difference between the highest and the lowest Aid flow (current US$) of Burundi?
Your answer should be compact. 2.92e+07. What is the difference between the highest and the lowest Aid flow (current US$) of Cote d'Ivoire?
Provide a succinct answer. 5.85e+07. What is the difference between the highest and the lowest Aid flow (current US$) of Guinea?
Provide a succinct answer. 1.07e+07. What is the difference between the highest and the lowest Aid flow (current US$) of Mali?
Ensure brevity in your answer.  3.40e+07. 